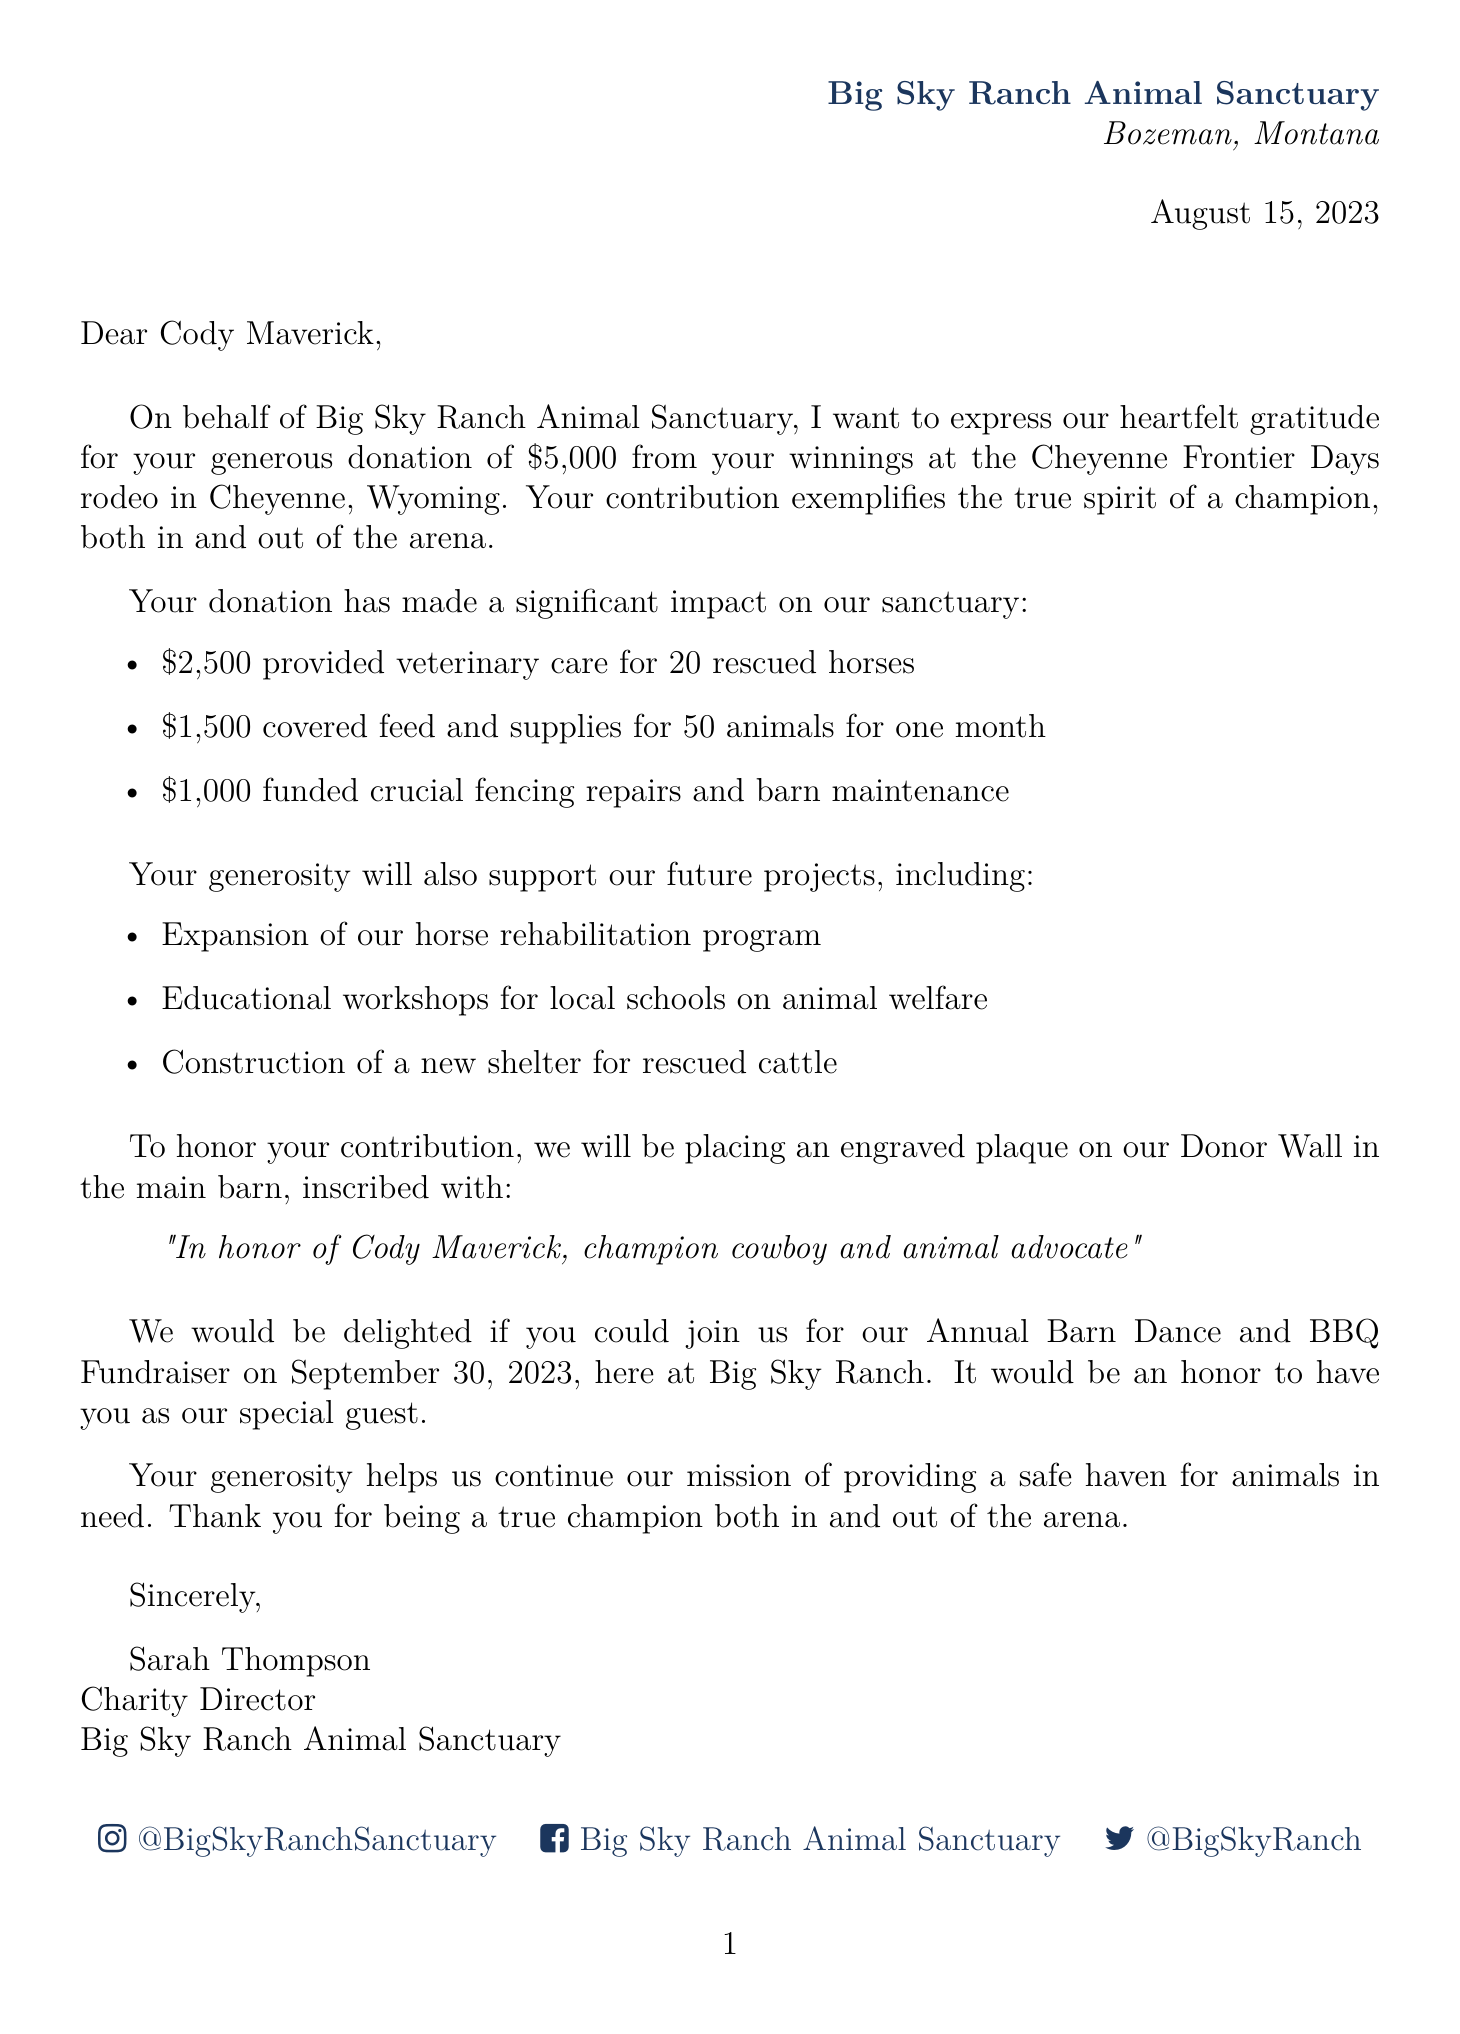what is the name of the charity? The name of the charity is explicitly mentioned in the document as Big Sky Ranch Animal Sanctuary.
Answer: Big Sky Ranch Animal Sanctuary who is the donor? The document identifies the donor by name as Cody Maverick.
Answer: Cody Maverick how much was the donation? The specific amount of the donation is listed in the letter as five thousand dollars.
Answer: $5,000 when was the donation made? The date of the donation is clearly stated in the document as August 15, 2023.
Answer: August 15, 2023 what event were the rodeo winnings from? The document specifies the event related to the rodeo winnings as Cheyenne Frontier Days.
Answer: Cheyenne Frontier Days how many rescued horses received veterinary care? The document notes that veterinary care was provided for twenty rescued horses.
Answer: 20 what is one of the future projects listed? The letter mentions future projects, including the expansion of the horse rehabilitation program as one of them.
Answer: Expansion of the horse rehabilitation program where will the engraved plaque be placed? The letter indicates that the engraved plaque will be placed on the Donor Wall in the main barn.
Answer: Donor Wall in the main barn what is the date of the upcoming fundraiser event? The document lists the date for the Annual Barn Dance and BBQ Fundraiser as September 30, 2023.
Answer: September 30, 2023 